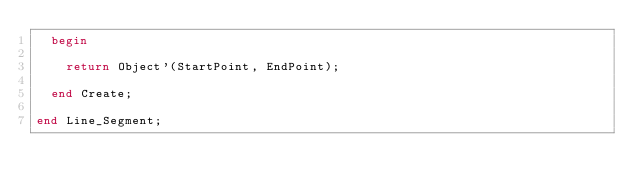Convert code to text. <code><loc_0><loc_0><loc_500><loc_500><_Ada_>  begin
  
    return Object'(StartPoint, EndPoint);
  
  end Create;

end Line_Segment;
</code> 